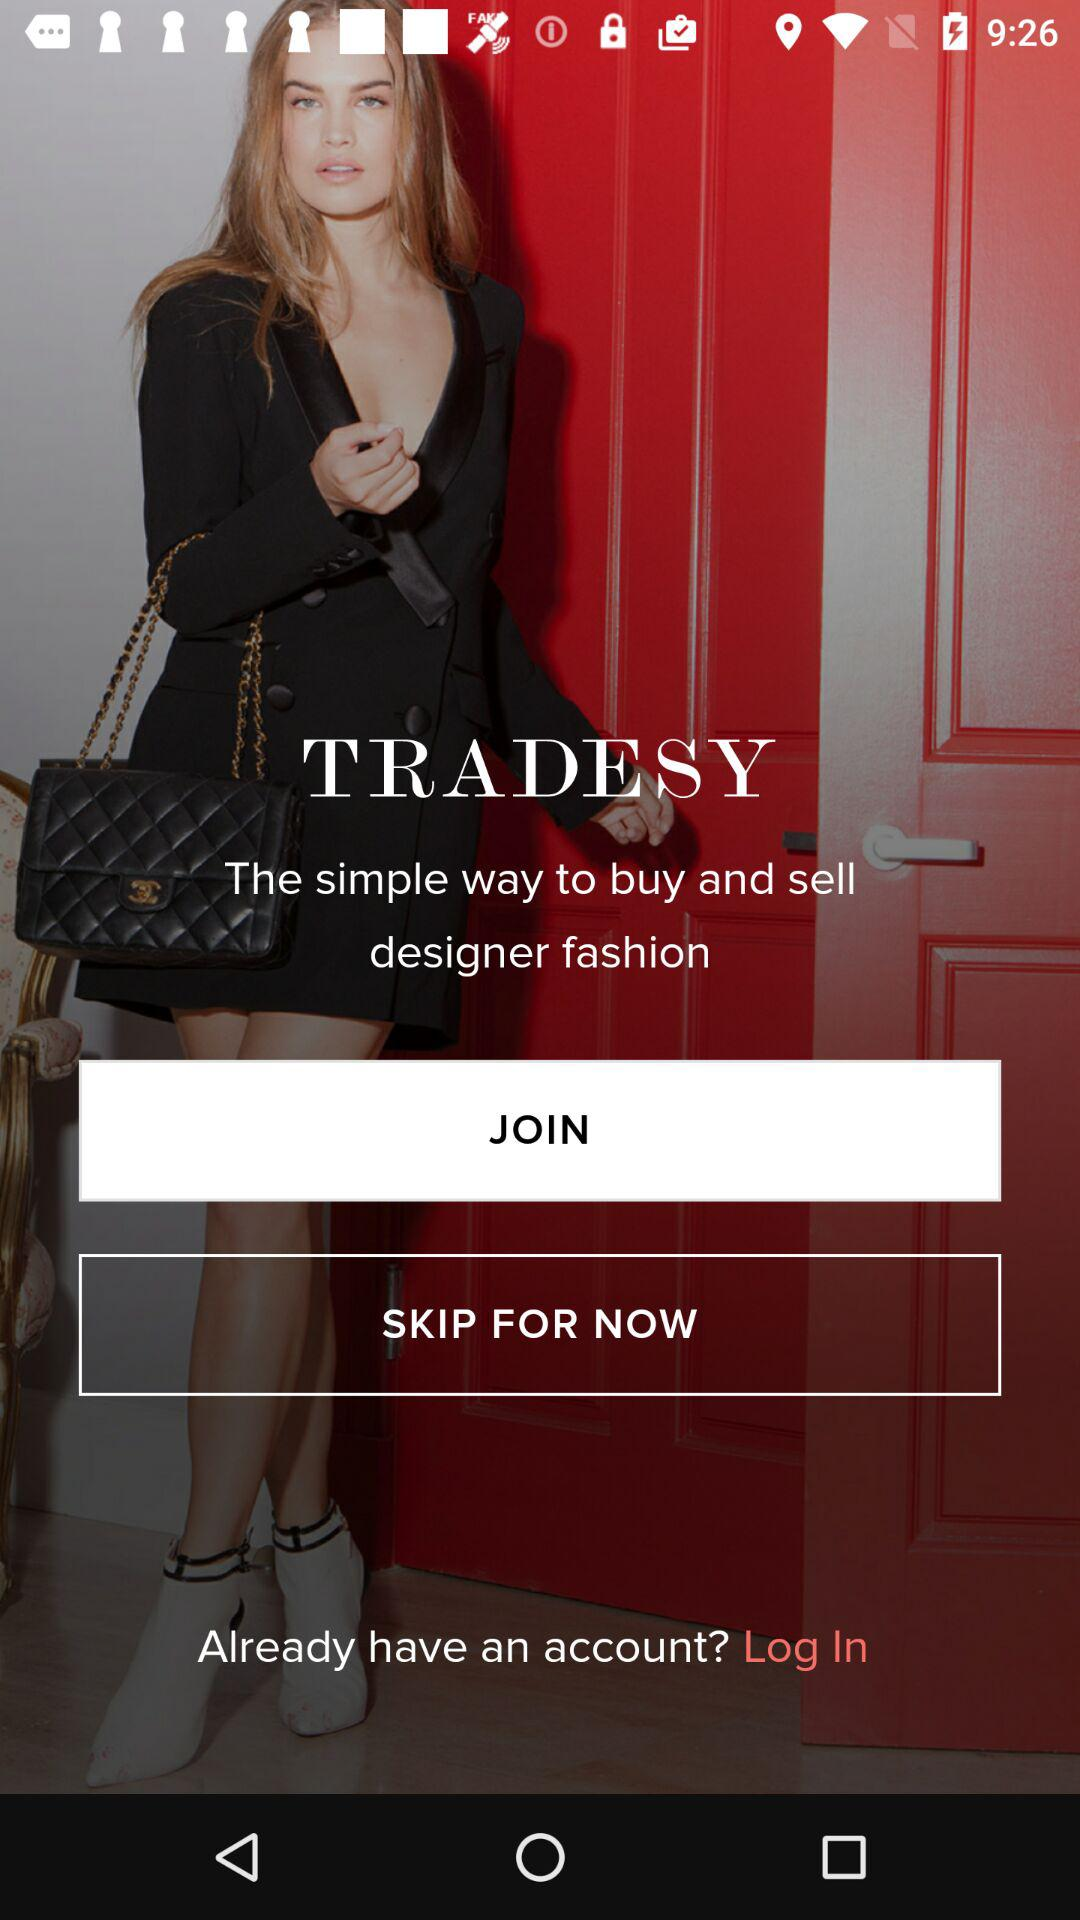What is the name of the application? The application name is "TRADESY". 